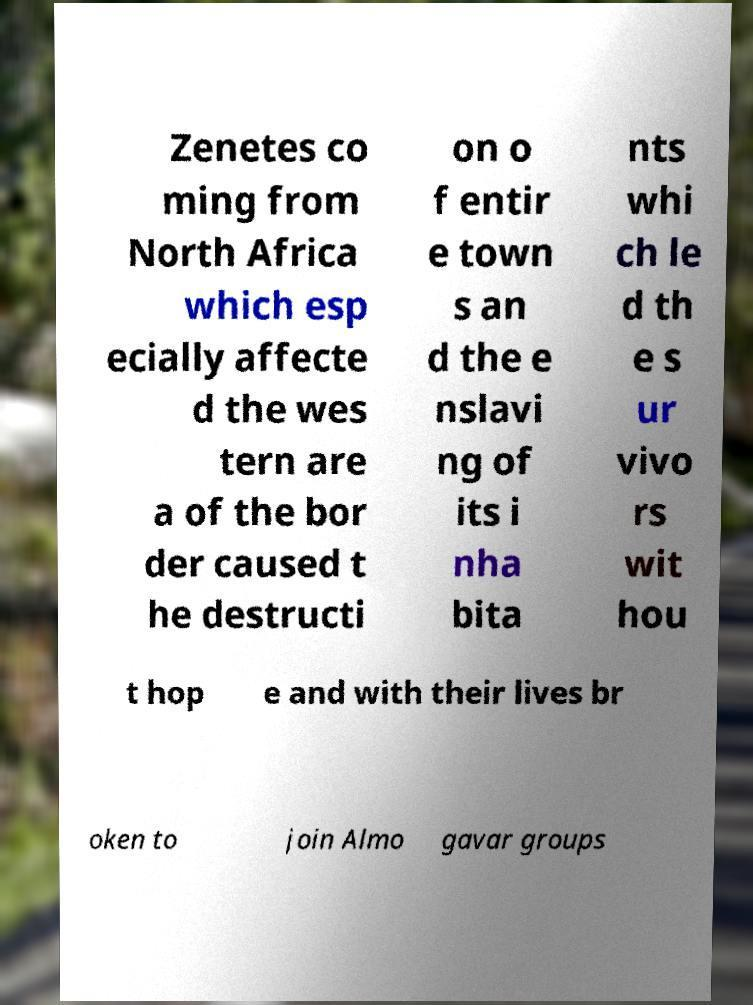Please read and relay the text visible in this image. What does it say? Zenetes co ming from North Africa which esp ecially affecte d the wes tern are a of the bor der caused t he destructi on o f entir e town s an d the e nslavi ng of its i nha bita nts whi ch le d th e s ur vivo rs wit hou t hop e and with their lives br oken to join Almo gavar groups 